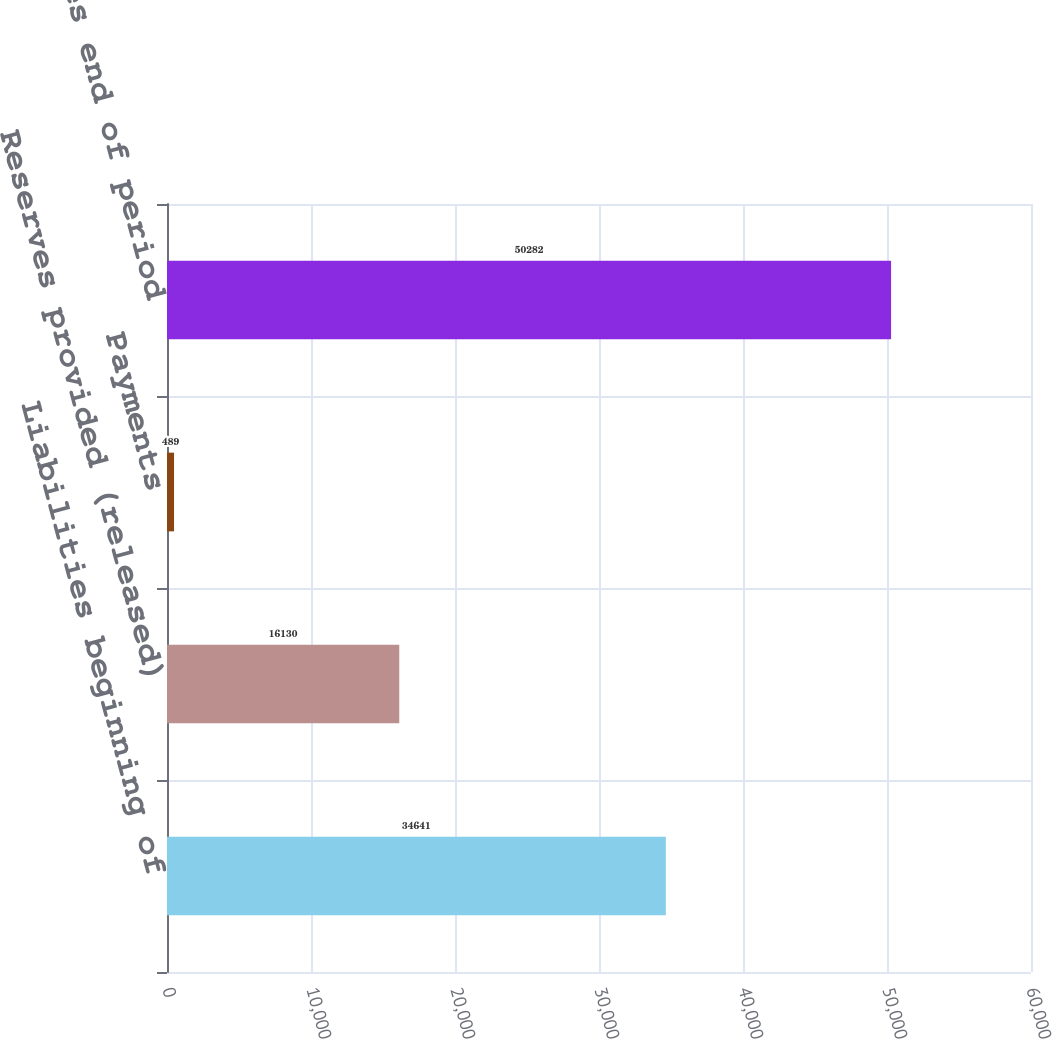Convert chart to OTSL. <chart><loc_0><loc_0><loc_500><loc_500><bar_chart><fcel>Liabilities beginning of<fcel>Reserves provided (released)<fcel>Payments<fcel>Liabilities end of period<nl><fcel>34641<fcel>16130<fcel>489<fcel>50282<nl></chart> 